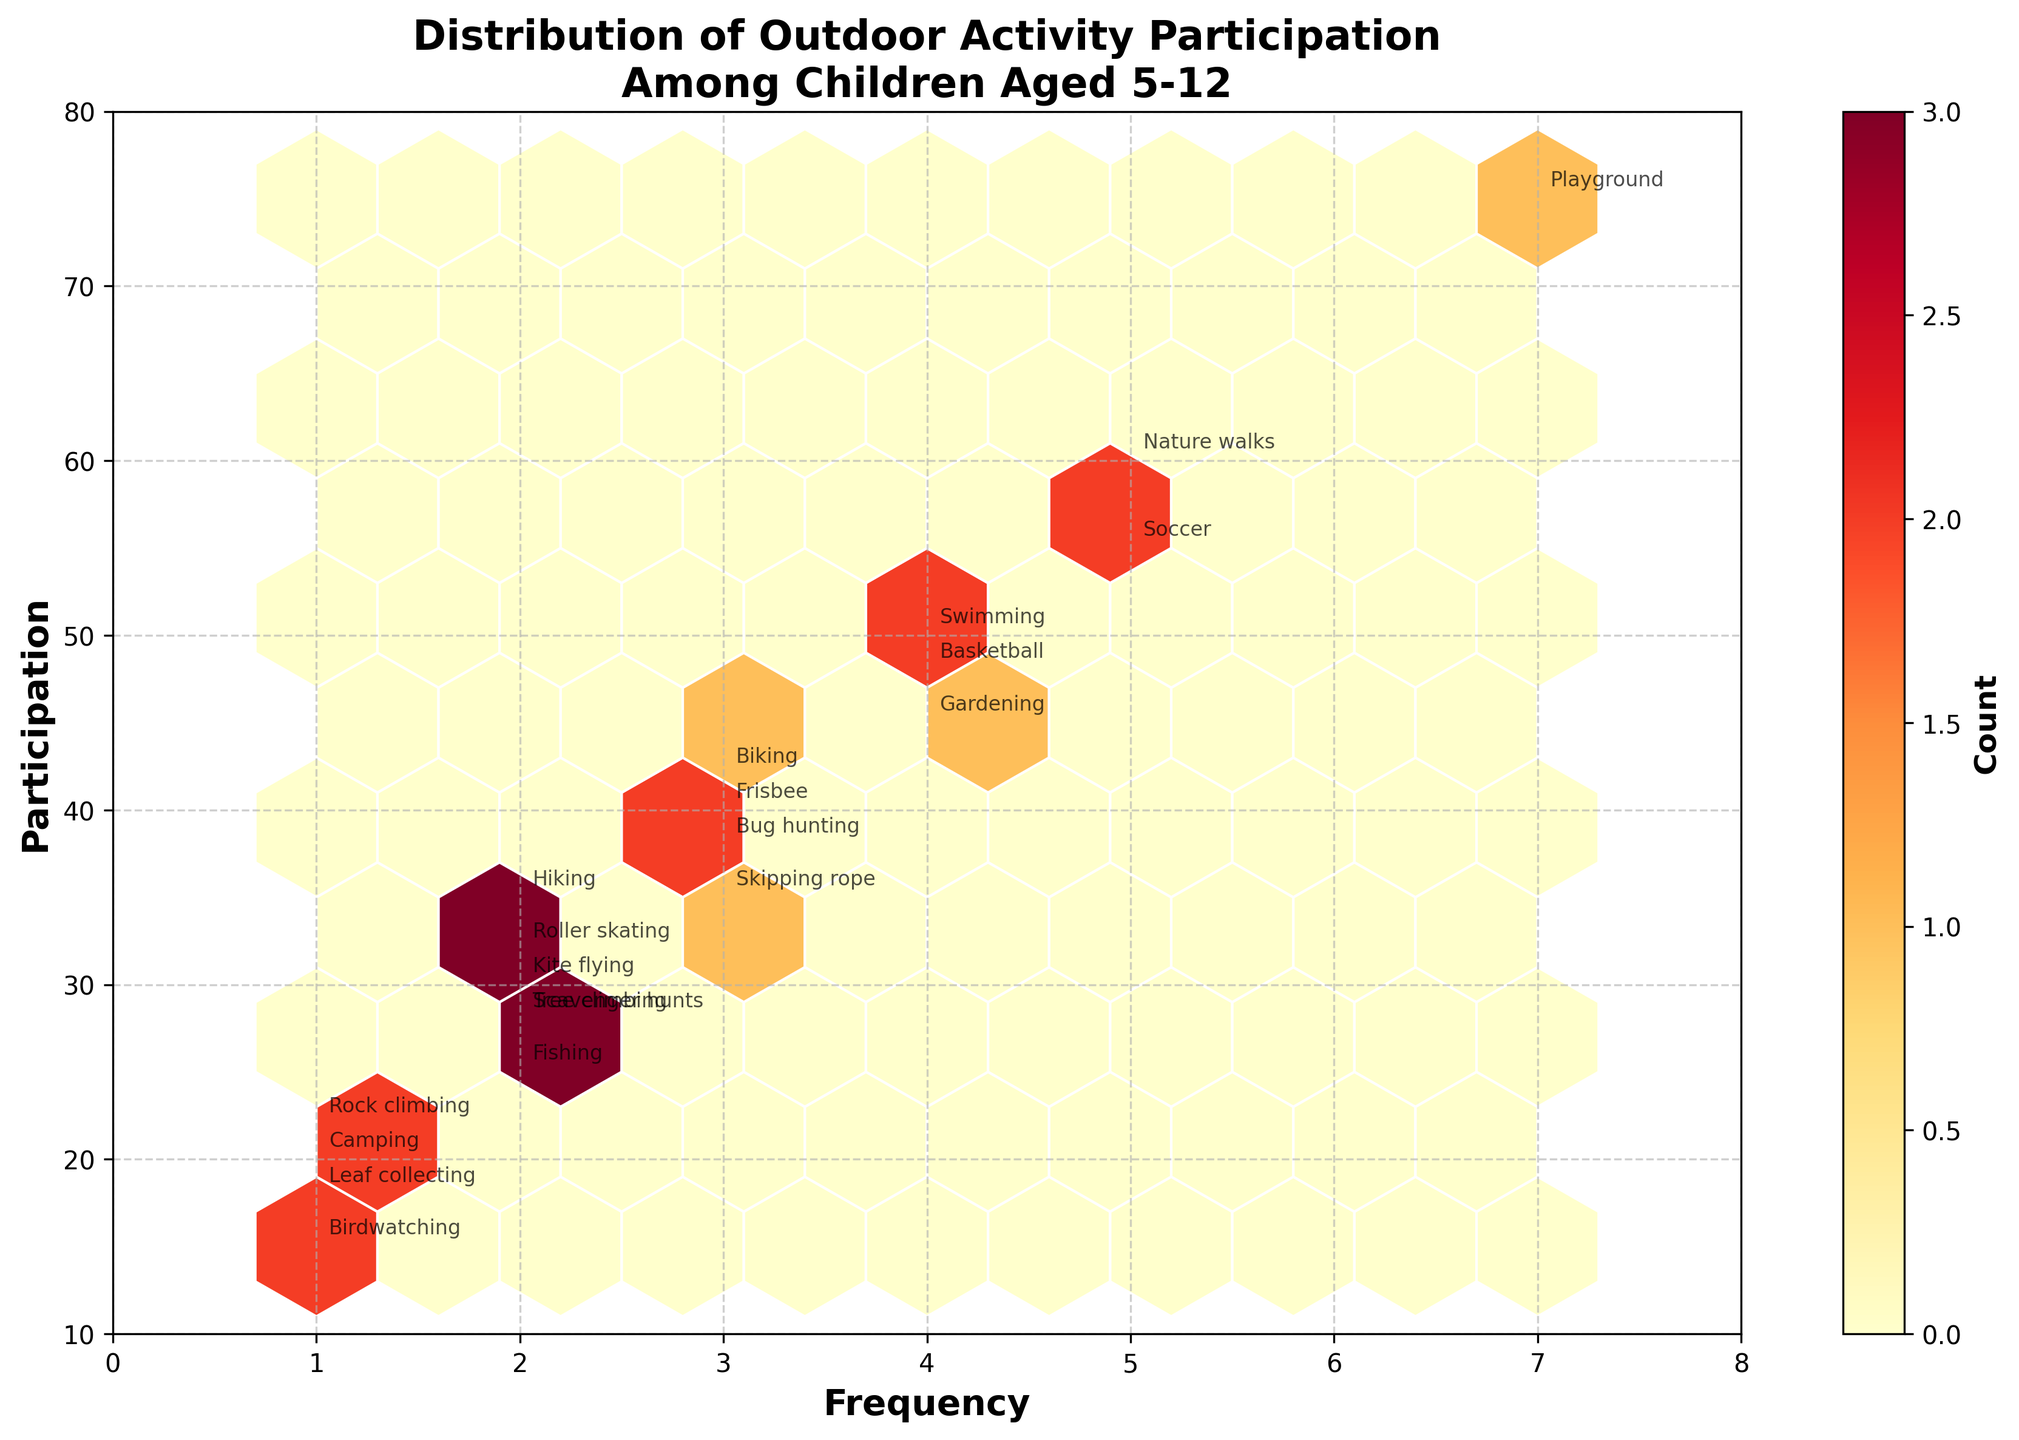What's the title of the plot? The figure shows a header that describes the overall content of the plot. The title is located at the top center of the plot.
Answer: Distribution of Outdoor Activity Participation Among Children Aged 5-12 What does the color represent in the Hexbin Plot? In a Hexbin Plot, the color indicates the concentration or count of data points within each hexagon area. A color bar on the right side of the plot labels colors ranging from light to dark corresponding to low to high counts.
Answer: Count of data points within each hexagon What's the range for the frequency of participation in the plot? The x-axis represents the frequency of participation. By examining the x-axis values from minimum to maximum, we can determine the range.
Answer: 0 to 8 Which activity has the highest participation and what is its frequency? Each activity is labeled next to the hexagon representing it. By locating the activity with the highest participation along the y-axis, we can identify the corresponding activity and its frequency on the x-axis.
Answer: Playground, 7 What is the participation count for activities with frequency 2? To find this information, we observe the y-axis values for all data points aligned vertically above frequency 2 on the x-axis and note their labels.
Answer: Hiking (35), Tree climbing (28), Kite flying (30), Fishing (25), Roller skating (32), Scavenger hunts (28) Among Biking, Swimming, and Nature Walks, which has the highest participation? By identifying the labeled points for Biking, Swimming, and Nature Walks on the plot and comparing their y-axis values, we can determine the one with the highest participation.
Answer: Nature Walks Is there an activity with a frequency of 1 and participation greater than 20? We examine the activities labeled at frequency 1 along the x-axis and check their corresponding y-axis values for any participation greater than 20.
Answer: Yes, Rock climbing (22) What is the average participation of activities with frequency 3? We need to sum up the participation counts of activities with frequency 3 and divide by the number of such activities. Activities are Biking (42), Bug hunting (38), Frisbee (40), and Skipping rope (35). The calculation involves multiple steps.
Answer: (42 + 38 + 40 + 35)/4 = 38.75 Compare the participation in Soccer and Basketball. Which one is higher? Identify the labeled positions of Soccer and Basketball on the plot, then compare their y-axis values to find out which one is higher.
Answer: Soccer Is there any activity with extremely low participation (approximately 10) regardless of frequency? Examine the lower end of the y-axis for activities whose participation reach down to around 10. Check if any activities have labels around that participation level.
Answer: No 